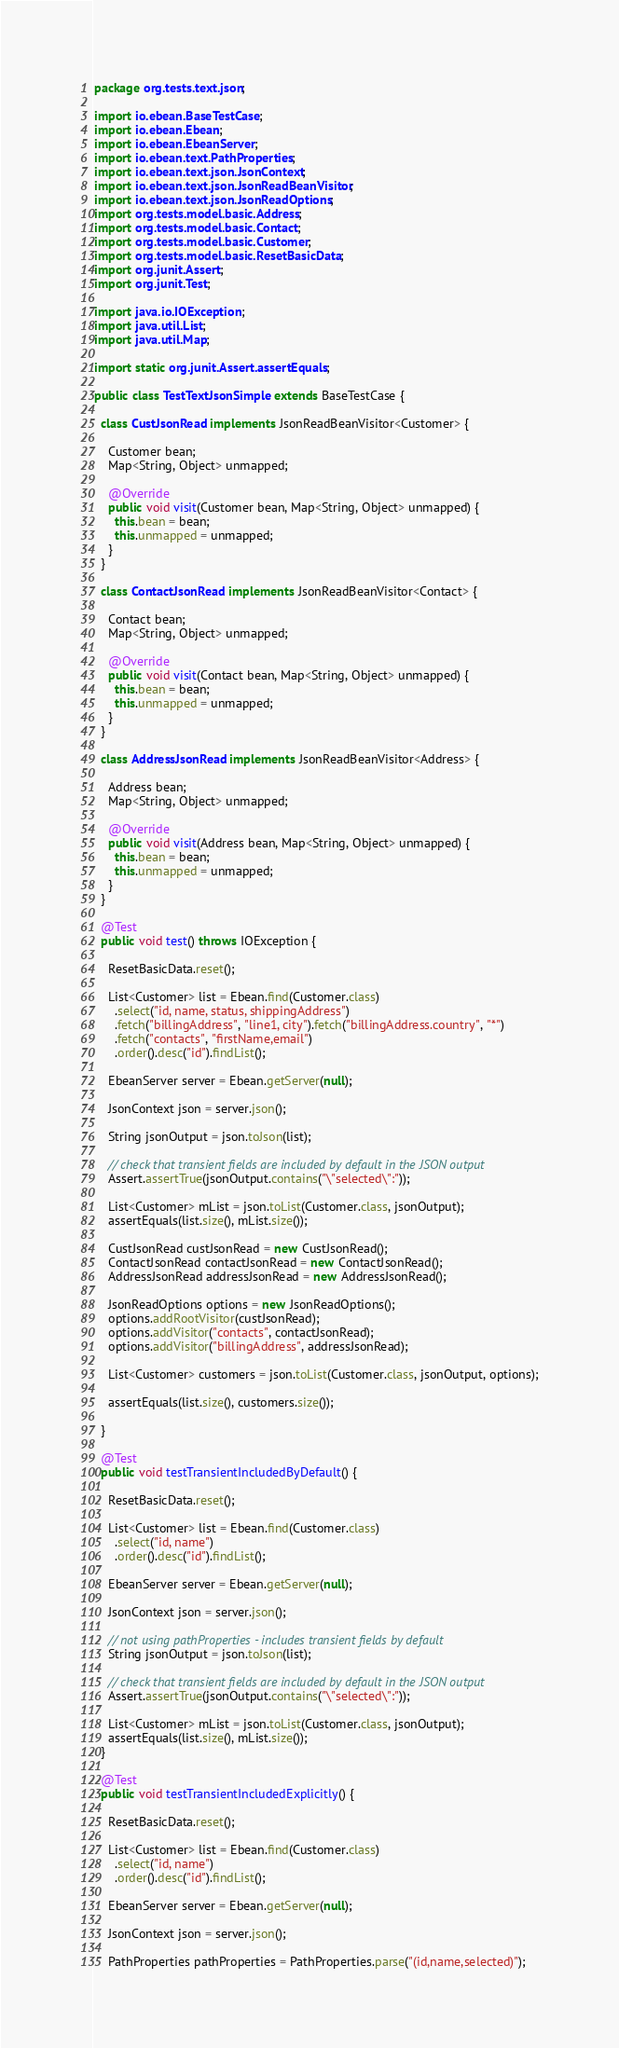<code> <loc_0><loc_0><loc_500><loc_500><_Java_>package org.tests.text.json;

import io.ebean.BaseTestCase;
import io.ebean.Ebean;
import io.ebean.EbeanServer;
import io.ebean.text.PathProperties;
import io.ebean.text.json.JsonContext;
import io.ebean.text.json.JsonReadBeanVisitor;
import io.ebean.text.json.JsonReadOptions;
import org.tests.model.basic.Address;
import org.tests.model.basic.Contact;
import org.tests.model.basic.Customer;
import org.tests.model.basic.ResetBasicData;
import org.junit.Assert;
import org.junit.Test;

import java.io.IOException;
import java.util.List;
import java.util.Map;

import static org.junit.Assert.assertEquals;

public class TestTextJsonSimple extends BaseTestCase {

  class CustJsonRead implements JsonReadBeanVisitor<Customer> {

    Customer bean;
    Map<String, Object> unmapped;

    @Override
    public void visit(Customer bean, Map<String, Object> unmapped) {
      this.bean = bean;
      this.unmapped = unmapped;
    }
  }

  class ContactJsonRead implements JsonReadBeanVisitor<Contact> {

    Contact bean;
    Map<String, Object> unmapped;

    @Override
    public void visit(Contact bean, Map<String, Object> unmapped) {
      this.bean = bean;
      this.unmapped = unmapped;
    }
  }

  class AddressJsonRead implements JsonReadBeanVisitor<Address> {

    Address bean;
    Map<String, Object> unmapped;

    @Override
    public void visit(Address bean, Map<String, Object> unmapped) {
      this.bean = bean;
      this.unmapped = unmapped;
    }
  }

  @Test
  public void test() throws IOException {

    ResetBasicData.reset();

    List<Customer> list = Ebean.find(Customer.class)
      .select("id, name, status, shippingAddress")
      .fetch("billingAddress", "line1, city").fetch("billingAddress.country", "*")
      .fetch("contacts", "firstName,email")
      .order().desc("id").findList();

    EbeanServer server = Ebean.getServer(null);

    JsonContext json = server.json();

    String jsonOutput = json.toJson(list);

    // check that transient fields are included by default in the JSON output
    Assert.assertTrue(jsonOutput.contains("\"selected\":"));

    List<Customer> mList = json.toList(Customer.class, jsonOutput);
    assertEquals(list.size(), mList.size());

    CustJsonRead custJsonRead = new CustJsonRead();
    ContactJsonRead contactJsonRead = new ContactJsonRead();
    AddressJsonRead addressJsonRead = new AddressJsonRead();

    JsonReadOptions options = new JsonReadOptions();
    options.addRootVisitor(custJsonRead);
    options.addVisitor("contacts", contactJsonRead);
    options.addVisitor("billingAddress", addressJsonRead);

    List<Customer> customers = json.toList(Customer.class, jsonOutput, options);

    assertEquals(list.size(), customers.size());

  }

  @Test
  public void testTransientIncludedByDefault() {

    ResetBasicData.reset();

    List<Customer> list = Ebean.find(Customer.class)
      .select("id, name")
      .order().desc("id").findList();

    EbeanServer server = Ebean.getServer(null);

    JsonContext json = server.json();

    // not using pathProperties - includes transient fields by default
    String jsonOutput = json.toJson(list);

    // check that transient fields are included by default in the JSON output
    Assert.assertTrue(jsonOutput.contains("\"selected\":"));

    List<Customer> mList = json.toList(Customer.class, jsonOutput);
    assertEquals(list.size(), mList.size());
  }

  @Test
  public void testTransientIncludedExplicitly() {

    ResetBasicData.reset();

    List<Customer> list = Ebean.find(Customer.class)
      .select("id, name")
      .order().desc("id").findList();

    EbeanServer server = Ebean.getServer(null);

    JsonContext json = server.json();

    PathProperties pathProperties = PathProperties.parse("(id,name,selected)");</code> 